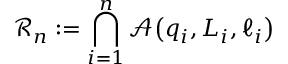Convert formula to latex. <formula><loc_0><loc_0><loc_500><loc_500>\ m a t h s c r { R } _ { n } \colon = \bigcap _ { i = 1 } ^ { n } \ m a t h s c r { A } \, \left ( q _ { i } , L _ { i } , \ell _ { i } \right )</formula> 